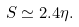<formula> <loc_0><loc_0><loc_500><loc_500>S \simeq 2 . 4 \eta .</formula> 